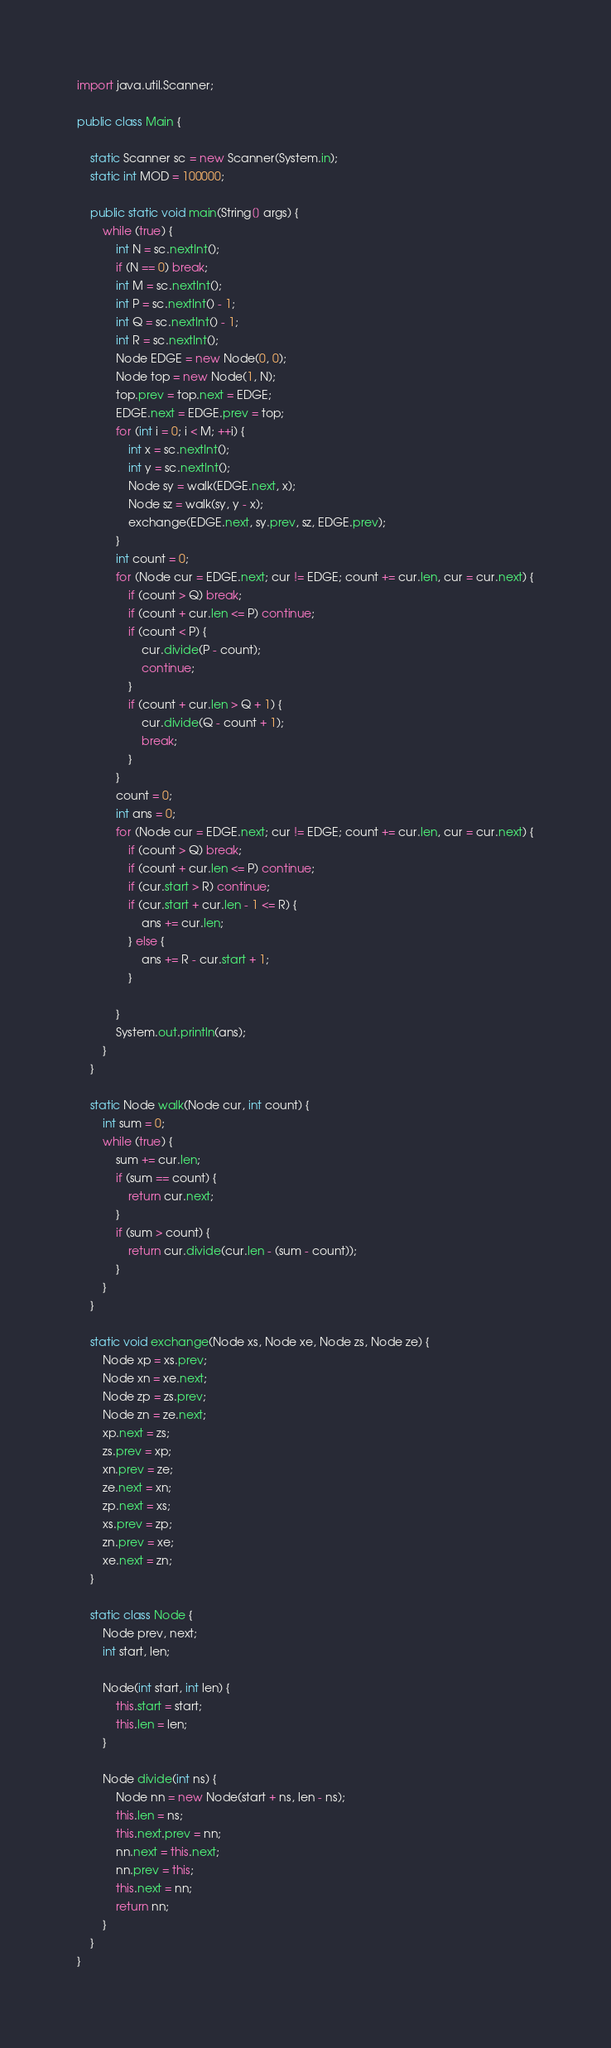Convert code to text. <code><loc_0><loc_0><loc_500><loc_500><_Java_>import java.util.Scanner;

public class Main {

	static Scanner sc = new Scanner(System.in);
	static int MOD = 100000;

	public static void main(String[] args) {
		while (true) {
			int N = sc.nextInt();
			if (N == 0) break;
			int M = sc.nextInt();
			int P = sc.nextInt() - 1;
			int Q = sc.nextInt() - 1;
			int R = sc.nextInt();
			Node EDGE = new Node(0, 0);
			Node top = new Node(1, N);
			top.prev = top.next = EDGE;
			EDGE.next = EDGE.prev = top;
			for (int i = 0; i < M; ++i) {
				int x = sc.nextInt();
				int y = sc.nextInt();
				Node sy = walk(EDGE.next, x);
				Node sz = walk(sy, y - x);
				exchange(EDGE.next, sy.prev, sz, EDGE.prev);
			}
			int count = 0;
			for (Node cur = EDGE.next; cur != EDGE; count += cur.len, cur = cur.next) {
				if (count > Q) break;
				if (count + cur.len <= P) continue;
				if (count < P) {
					cur.divide(P - count);
					continue;
				}
				if (count + cur.len > Q + 1) {
					cur.divide(Q - count + 1);
					break;
				}
			}
			count = 0;
			int ans = 0;
			for (Node cur = EDGE.next; cur != EDGE; count += cur.len, cur = cur.next) {
				if (count > Q) break;
				if (count + cur.len <= P) continue;
				if (cur.start > R) continue;
				if (cur.start + cur.len - 1 <= R) {
					ans += cur.len;
				} else {
					ans += R - cur.start + 1;
				}

			}
			System.out.println(ans);
		}
	}

	static Node walk(Node cur, int count) {
		int sum = 0;
		while (true) {
			sum += cur.len;
			if (sum == count) {
				return cur.next;
			}
			if (sum > count) {
				return cur.divide(cur.len - (sum - count));
			}
		}
	}

	static void exchange(Node xs, Node xe, Node zs, Node ze) {
		Node xp = xs.prev;
		Node xn = xe.next;
		Node zp = zs.prev;
		Node zn = ze.next;
		xp.next = zs;
		zs.prev = xp;
		xn.prev = ze;
		ze.next = xn;
		zp.next = xs;
		xs.prev = zp;
		zn.prev = xe;
		xe.next = zn;
	}

	static class Node {
		Node prev, next;
		int start, len;

		Node(int start, int len) {
			this.start = start;
			this.len = len;
		}

		Node divide(int ns) {
			Node nn = new Node(start + ns, len - ns);
			this.len = ns;
			this.next.prev = nn;
			nn.next = this.next;
			nn.prev = this;
			this.next = nn;
			return nn;
		}
	}
}</code> 